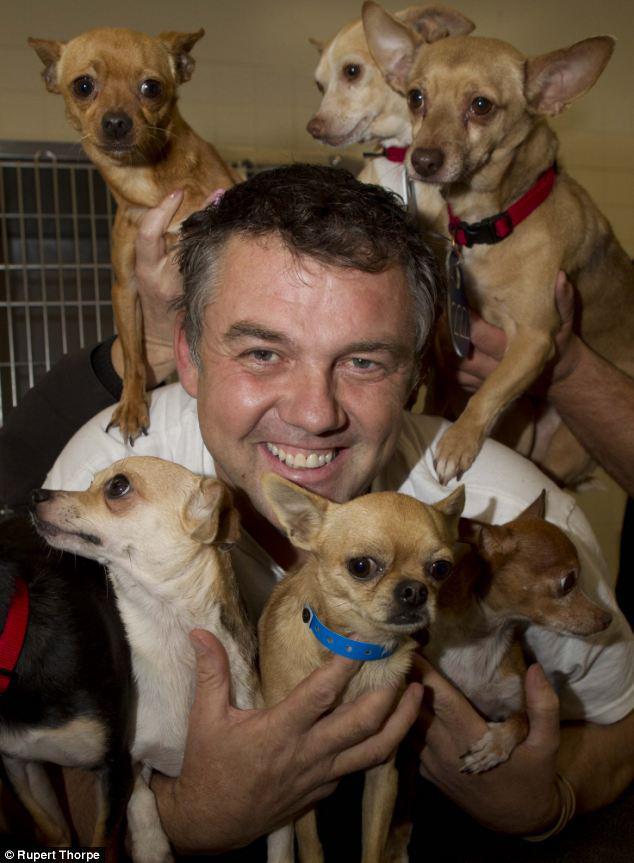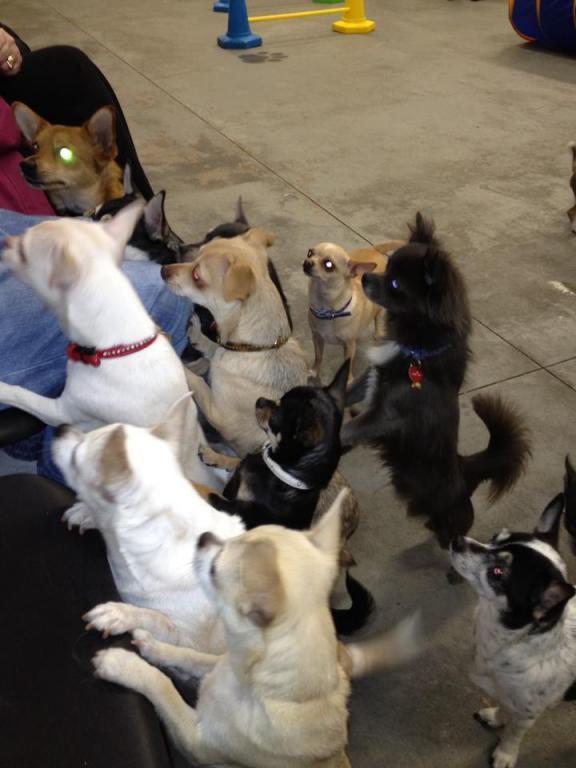The first image is the image on the left, the second image is the image on the right. Considering the images on both sides, is "In at least one image, there is only one dog." valid? Answer yes or no. No. The first image is the image on the left, the second image is the image on the right. Considering the images on both sides, is "At least one of the images contains only one chihuahuas." valid? Answer yes or no. No. 